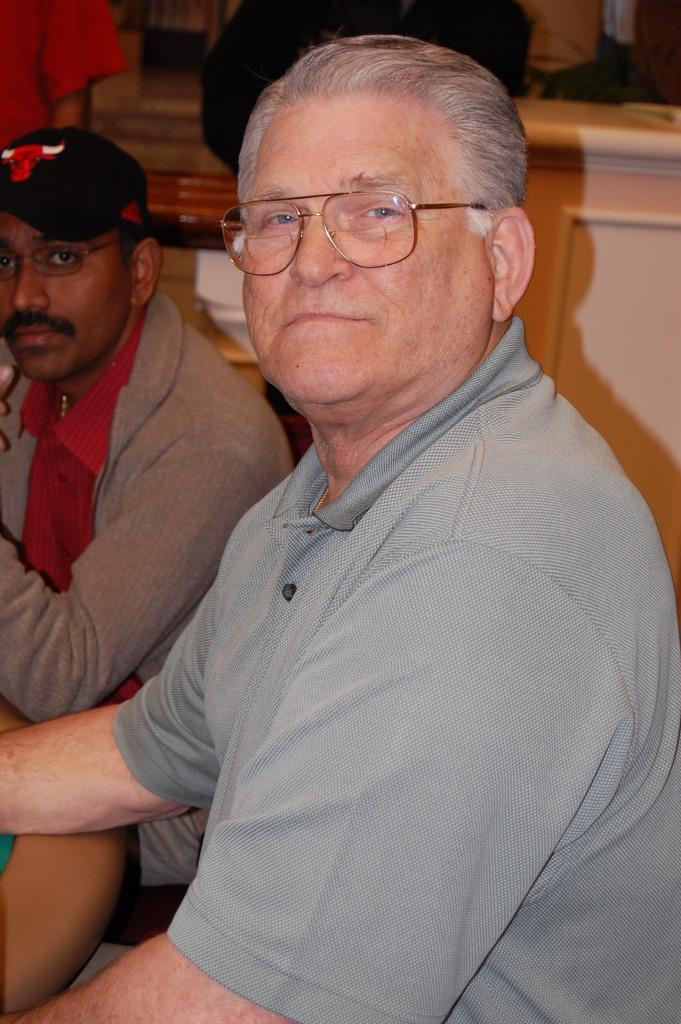How many people with spectacles can be seen in the image? There are two people with spectacles in the image. What type of headwear is worn by one of the people in the image? There is a person with a cap in the image. Can you describe the positioning of the people in the image? There are two people standing behind the main subjects in the image. What can be seen in the background of the image? There are some objects visible in the background of the image. What type of street is visible in the background of the image? There is no street visible in the background of the image; it only contains some objects. 